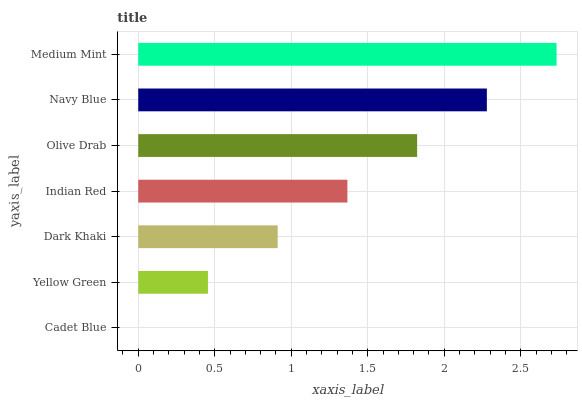Is Cadet Blue the minimum?
Answer yes or no. Yes. Is Medium Mint the maximum?
Answer yes or no. Yes. Is Yellow Green the minimum?
Answer yes or no. No. Is Yellow Green the maximum?
Answer yes or no. No. Is Yellow Green greater than Cadet Blue?
Answer yes or no. Yes. Is Cadet Blue less than Yellow Green?
Answer yes or no. Yes. Is Cadet Blue greater than Yellow Green?
Answer yes or no. No. Is Yellow Green less than Cadet Blue?
Answer yes or no. No. Is Indian Red the high median?
Answer yes or no. Yes. Is Indian Red the low median?
Answer yes or no. Yes. Is Dark Khaki the high median?
Answer yes or no. No. Is Cadet Blue the low median?
Answer yes or no. No. 